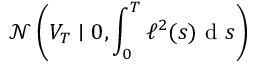Convert formula to latex. <formula><loc_0><loc_0><loc_500><loc_500>\mathcal { N } \left ( V _ { T } | 0 , \int _ { 0 } ^ { T } \ell ^ { 2 } ( s ) d s \right )</formula> 